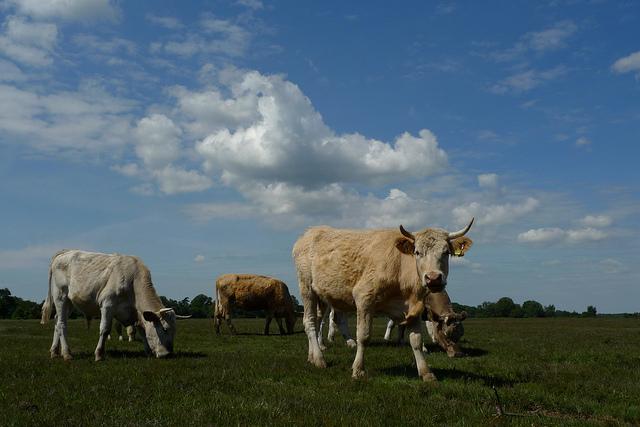Do you think this is a winter scene?
Give a very brief answer. No. How many of the cattle are not grazing?
Concise answer only. 1. Are these Nags?
Give a very brief answer. No. What kind of animals are shown?
Quick response, please. Cows. Is this a bull?
Answer briefly. Yes. What animal is this?
Quick response, please. Cow. What kind of animal is this?
Write a very short answer. Cow. Are the animals climbing a mountain?
Write a very short answer. No. Which of these animals is larger?
Short answer required. Bull. How many cows are there?
Keep it brief. 4. What is a group of elephants called?
Keep it brief. Herd. What country is this image from?
Quick response, please. America. What can be seen in the background?
Write a very short answer. Trees. Are these cows going to be eaten?
Keep it brief. No. Do any of the cows have horns?
Write a very short answer. Yes. What kind of animals are these?
Short answer required. Cows. 